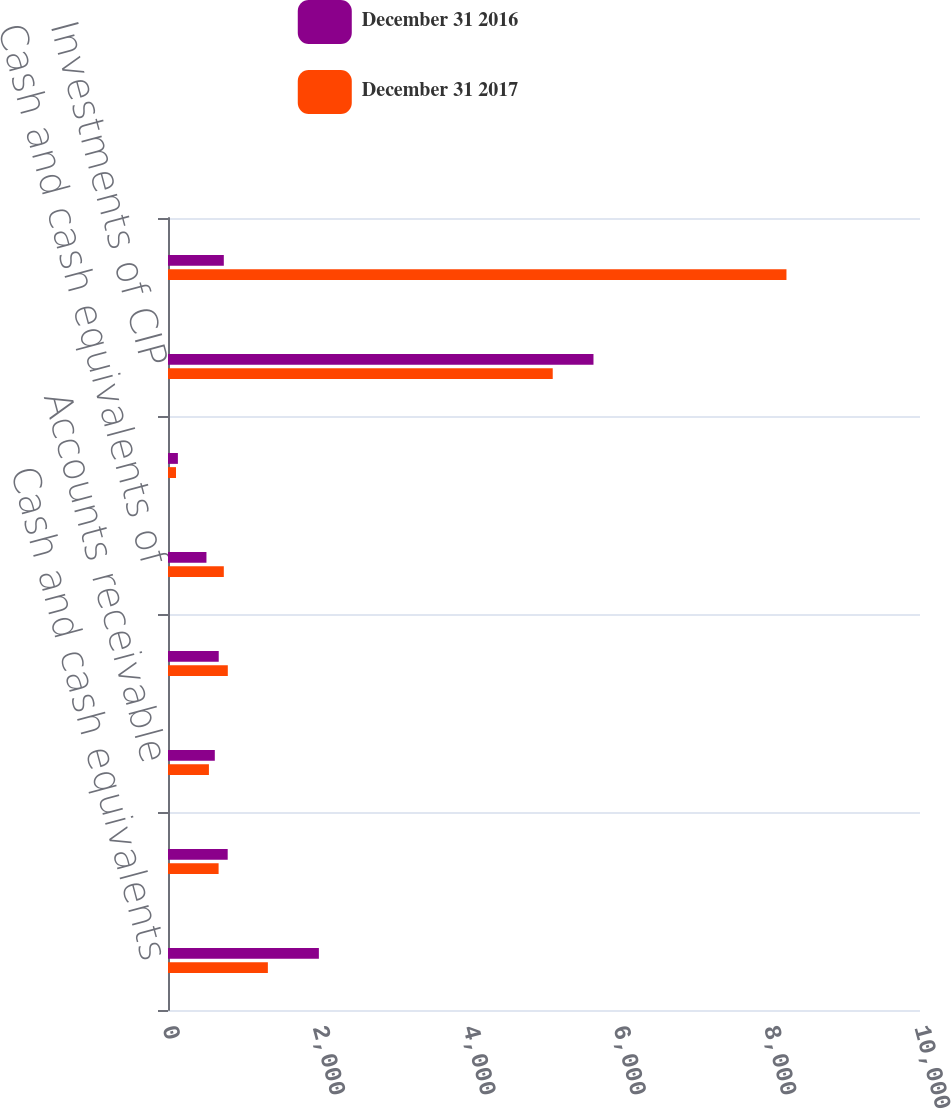Convert chart to OTSL. <chart><loc_0><loc_0><loc_500><loc_500><stacked_bar_chart><ecel><fcel>Cash and cash equivalents<fcel>Unsettled fund receivables<fcel>Accounts receivable<fcel>Investments<fcel>Cash and cash equivalents of<fcel>Accounts receivable and other<fcel>Investments of CIP<fcel>Assets held for policyholders<nl><fcel>December 31 2016<fcel>2006.4<fcel>793.8<fcel>622.5<fcel>674.6<fcel>511.3<fcel>131.5<fcel>5658<fcel>742.2<nl><fcel>December 31 2017<fcel>1328<fcel>672.9<fcel>544.2<fcel>795.3<fcel>742.2<fcel>106.2<fcel>5116.1<fcel>8224.2<nl></chart> 